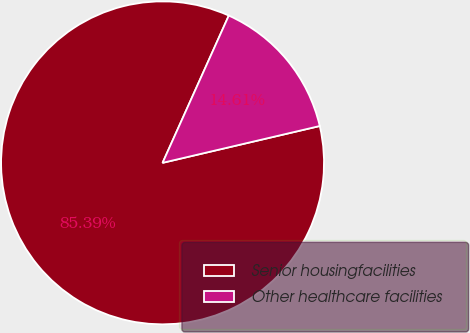<chart> <loc_0><loc_0><loc_500><loc_500><pie_chart><fcel>Senior housingfacilities<fcel>Other healthcare facilities<nl><fcel>85.39%<fcel>14.61%<nl></chart> 